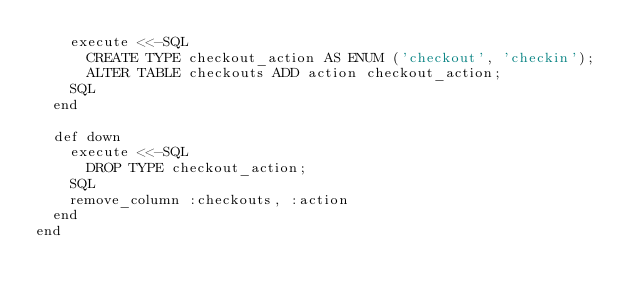Convert code to text. <code><loc_0><loc_0><loc_500><loc_500><_Ruby_>    execute <<-SQL
      CREATE TYPE checkout_action AS ENUM ('checkout', 'checkin');
      ALTER TABLE checkouts ADD action checkout_action;
    SQL
  end

  def down
    execute <<-SQL
      DROP TYPE checkout_action;
    SQL
    remove_column :checkouts, :action
  end
end
</code> 